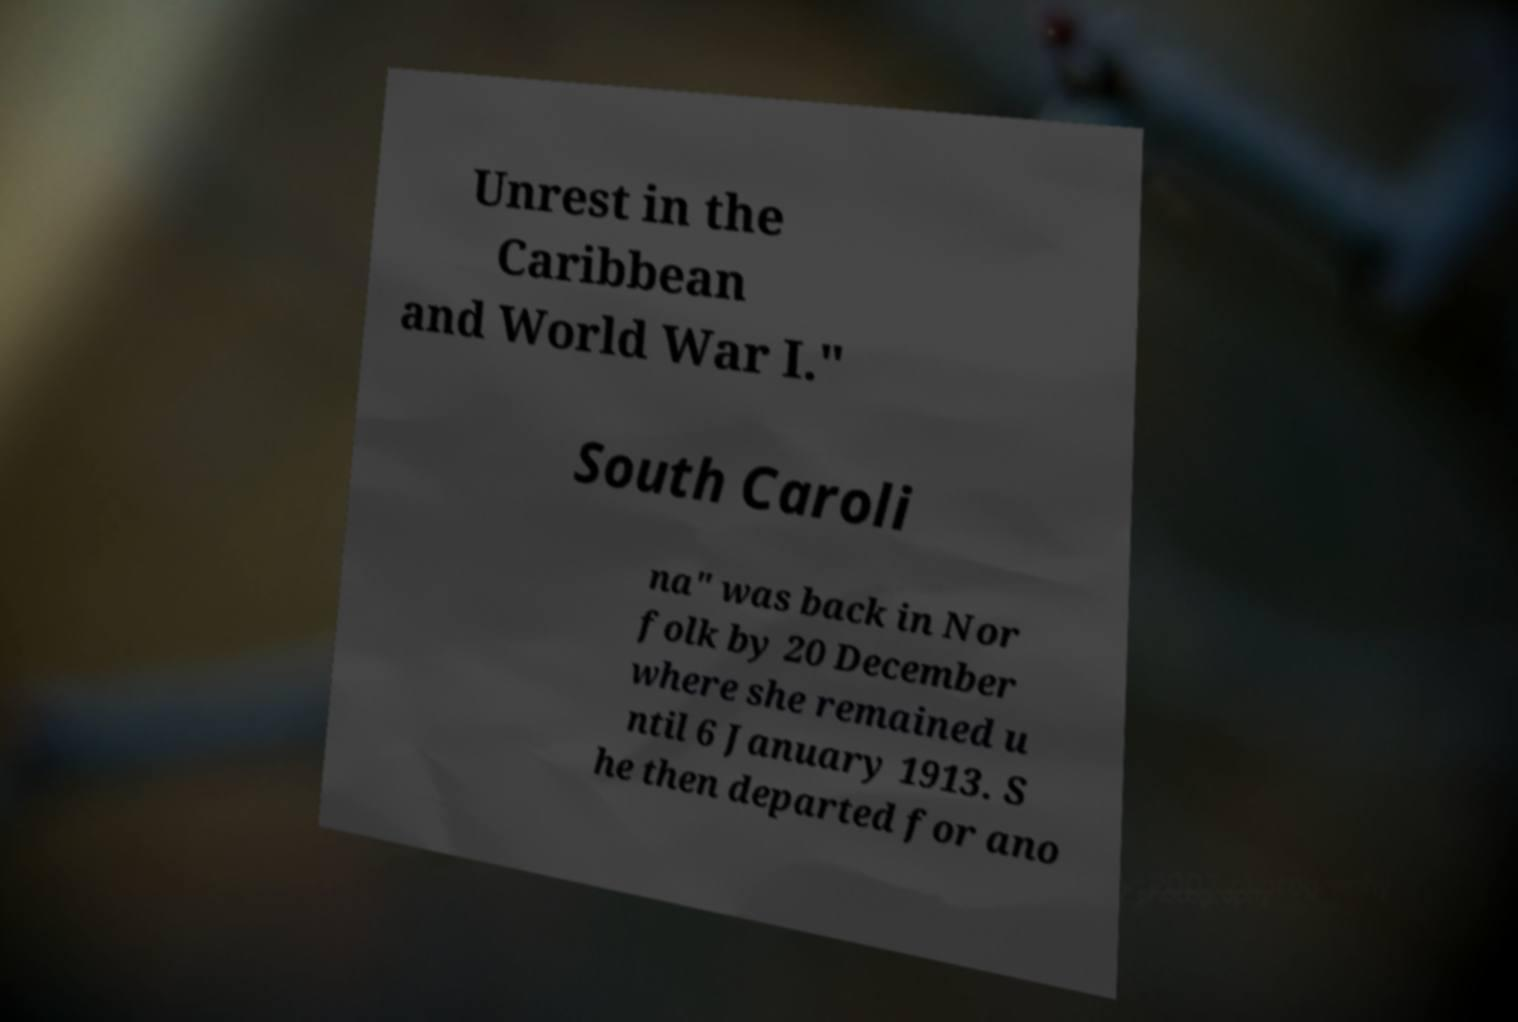Please read and relay the text visible in this image. What does it say? Unrest in the Caribbean and World War I." South Caroli na" was back in Nor folk by 20 December where she remained u ntil 6 January 1913. S he then departed for ano 